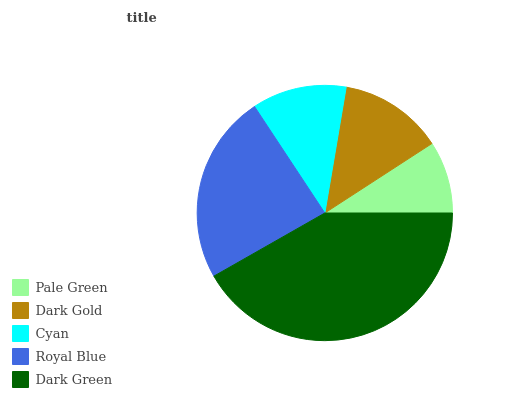Is Pale Green the minimum?
Answer yes or no. Yes. Is Dark Green the maximum?
Answer yes or no. Yes. Is Dark Gold the minimum?
Answer yes or no. No. Is Dark Gold the maximum?
Answer yes or no. No. Is Dark Gold greater than Pale Green?
Answer yes or no. Yes. Is Pale Green less than Dark Gold?
Answer yes or no. Yes. Is Pale Green greater than Dark Gold?
Answer yes or no. No. Is Dark Gold less than Pale Green?
Answer yes or no. No. Is Dark Gold the high median?
Answer yes or no. Yes. Is Dark Gold the low median?
Answer yes or no. Yes. Is Cyan the high median?
Answer yes or no. No. Is Royal Blue the low median?
Answer yes or no. No. 